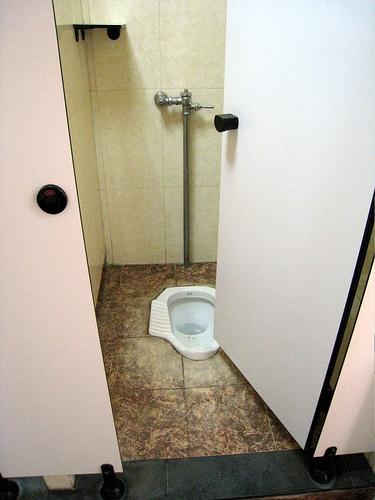How many bathroom stalls are shown?
Answer briefly. 1. Do these bathrooms have doors?
Quick response, please. Yes. Is that a toilet on the floor?
Keep it brief. Yes. Is this a public restroom?
Give a very brief answer. Yes. 